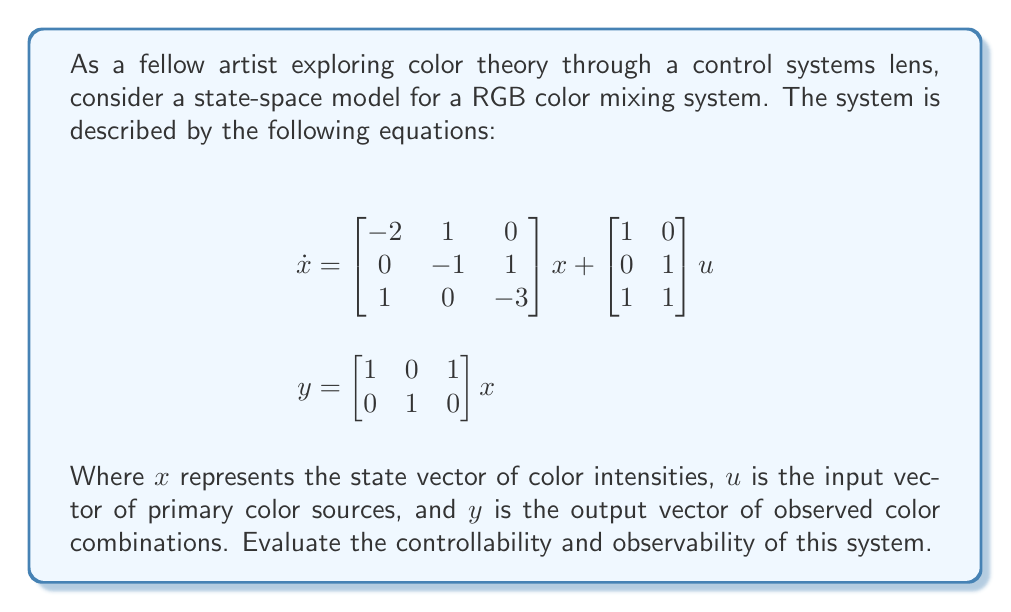Help me with this question. To evaluate the controllability and observability of this state-space model, we need to check the rank of the controllability and observability matrices.

1. Controllability:
The controllability matrix is given by $C = [B \quad AB \quad A^2B]$, where $A$ is the state matrix and $B$ is the input matrix.

$$A = \begin{bmatrix} -2 & 1 & 0 \\ 0 & -1 & 1 \\ 1 & 0 & -3 \end{bmatrix}, \quad B = \begin{bmatrix} 1 & 0 \\ 0 & 1 \\ 1 & 1 \end{bmatrix}$$

Calculate $AB$ and $A^2B$:

$$AB = \begin{bmatrix} -2 & -1 \\ -1 & 0 \\ -2 & -2 \end{bmatrix}$$

$$A^2B = \begin{bmatrix} 3 & 2 \\ 1 & 2 \\ 4 & 5 \end{bmatrix}$$

Now, form the controllability matrix:

$$C = \begin{bmatrix} 1 & 0 & -2 & -1 & 3 & 2 \\ 0 & 1 & -1 & 0 & 1 & 2 \\ 1 & 1 & -2 & -2 & 4 & 5 \end{bmatrix}$$

The rank of $C$ is 3, which is equal to the number of states. Therefore, the system is controllable.

2. Observability:
The observability matrix is given by $O = [C^T \quad A^TC^T \quad (A^T)^2C^T]$, where $C$ is the output matrix.

$$C = \begin{bmatrix} 1 & 0 & 1 \\ 0 & 1 & 0 \end{bmatrix}$$

Calculate $A^TC^T$ and $(A^T)^2C^T$:

$$A^TC^T = \begin{bmatrix} -2 & 0 \\ 1 & -1 \\ 0 & 1 \end{bmatrix}$$

$$(A^T)^2C^T = \begin{bmatrix} 5 & -1 \\ -3 & 1 \\ -1 & -1 \end{bmatrix}$$

Now, form the observability matrix:

$$O = \begin{bmatrix} 1 & 0 & -2 & 0 & 5 & -1 \\ 0 & 1 & 1 & -1 & -3 & 1 \\ 1 & 0 & 0 & 1 & -1 & -1 \end{bmatrix}$$

The rank of $O$ is 3, which is equal to the number of states. Therefore, the system is observable.
Answer: The system is both controllable and observable, as the ranks of both the controllability matrix $C$ and the observability matrix $O$ are equal to the number of states (3). 